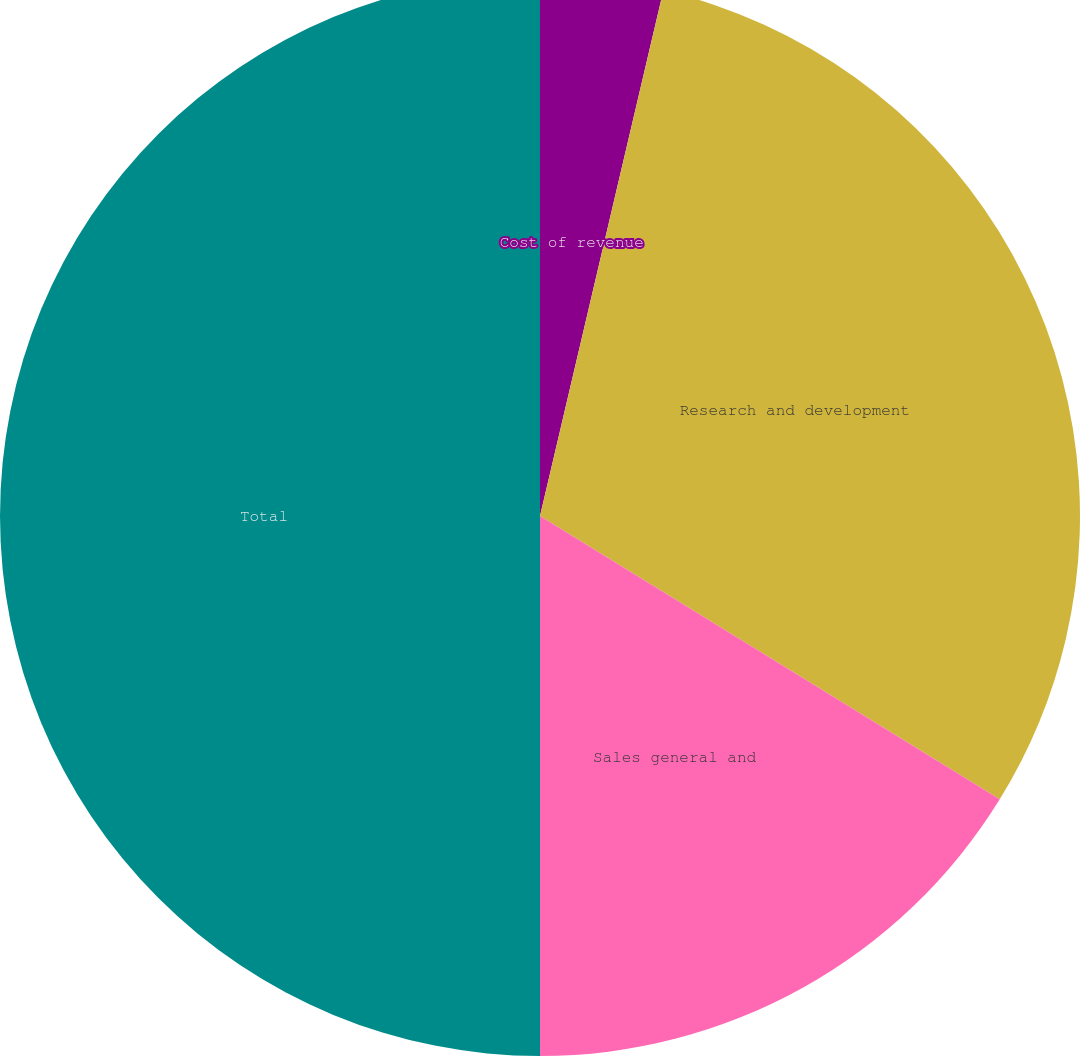<chart> <loc_0><loc_0><loc_500><loc_500><pie_chart><fcel>Cost of revenue<fcel>Research and development<fcel>Sales general and<fcel>Total<nl><fcel>3.67%<fcel>30.12%<fcel>16.21%<fcel>50.0%<nl></chart> 